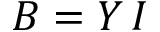<formula> <loc_0><loc_0><loc_500><loc_500>B = Y \, I</formula> 